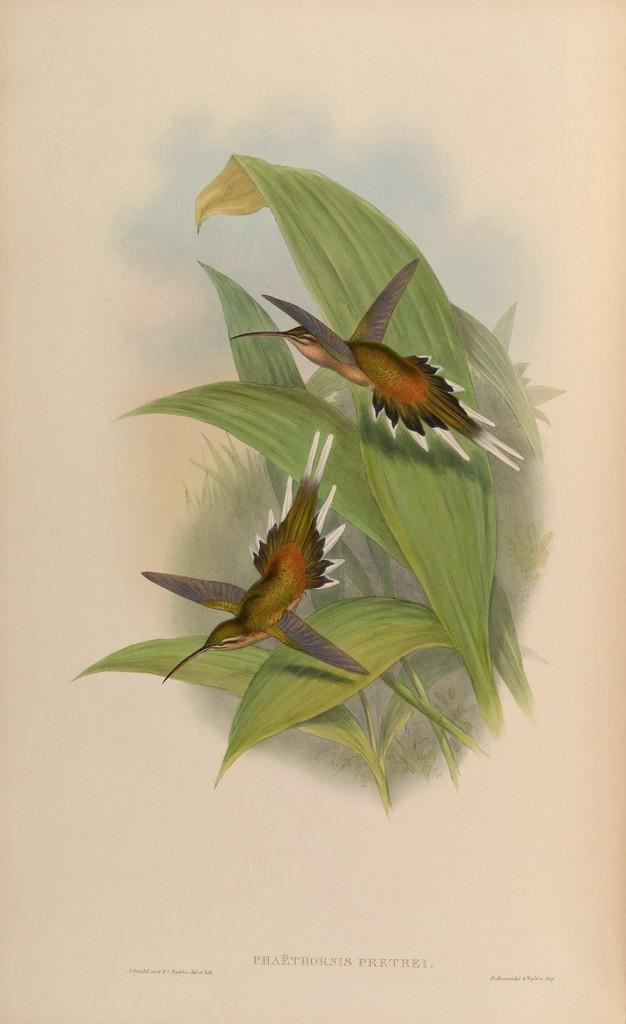Please provide a concise description of this image. This image consists of a painting of two birds and plants. At the bottom of this image I can see some text. 